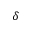Convert formula to latex. <formula><loc_0><loc_0><loc_500><loc_500>\delta</formula> 